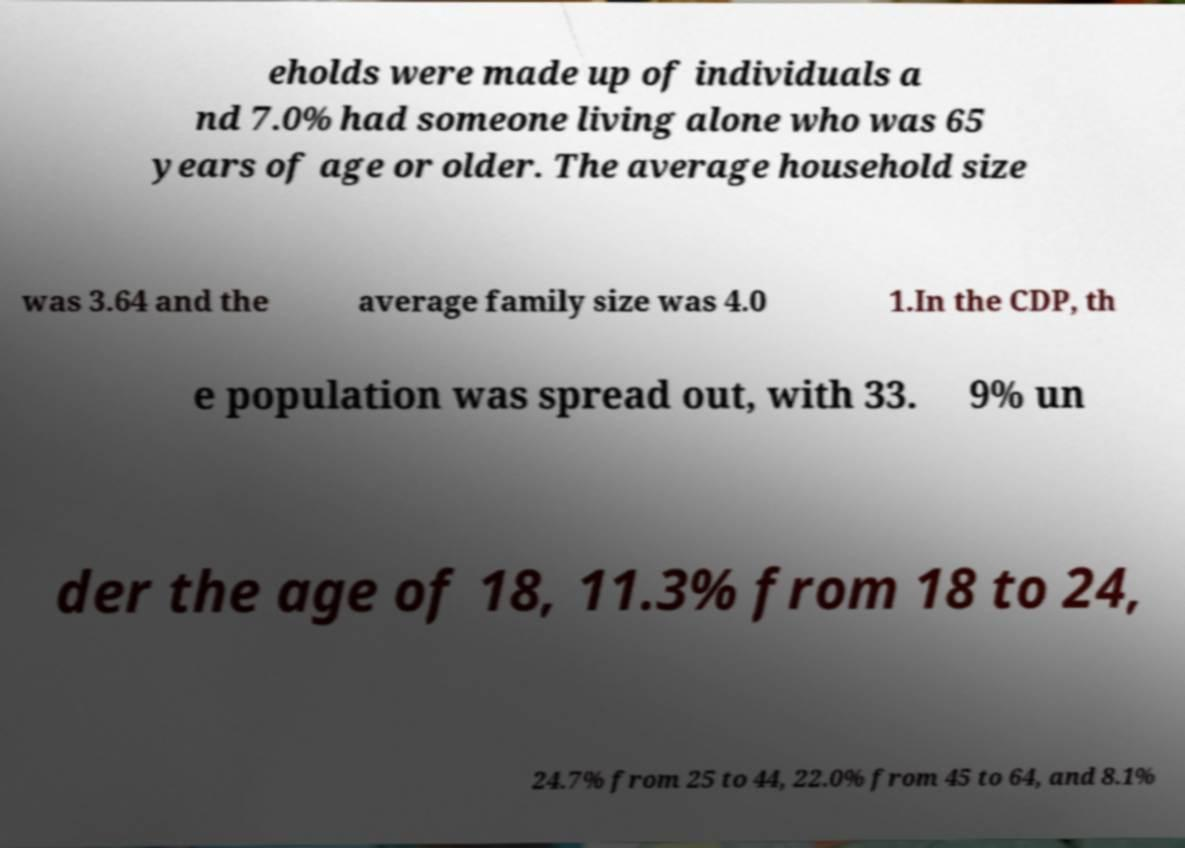Could you extract and type out the text from this image? eholds were made up of individuals a nd 7.0% had someone living alone who was 65 years of age or older. The average household size was 3.64 and the average family size was 4.0 1.In the CDP, th e population was spread out, with 33. 9% un der the age of 18, 11.3% from 18 to 24, 24.7% from 25 to 44, 22.0% from 45 to 64, and 8.1% 